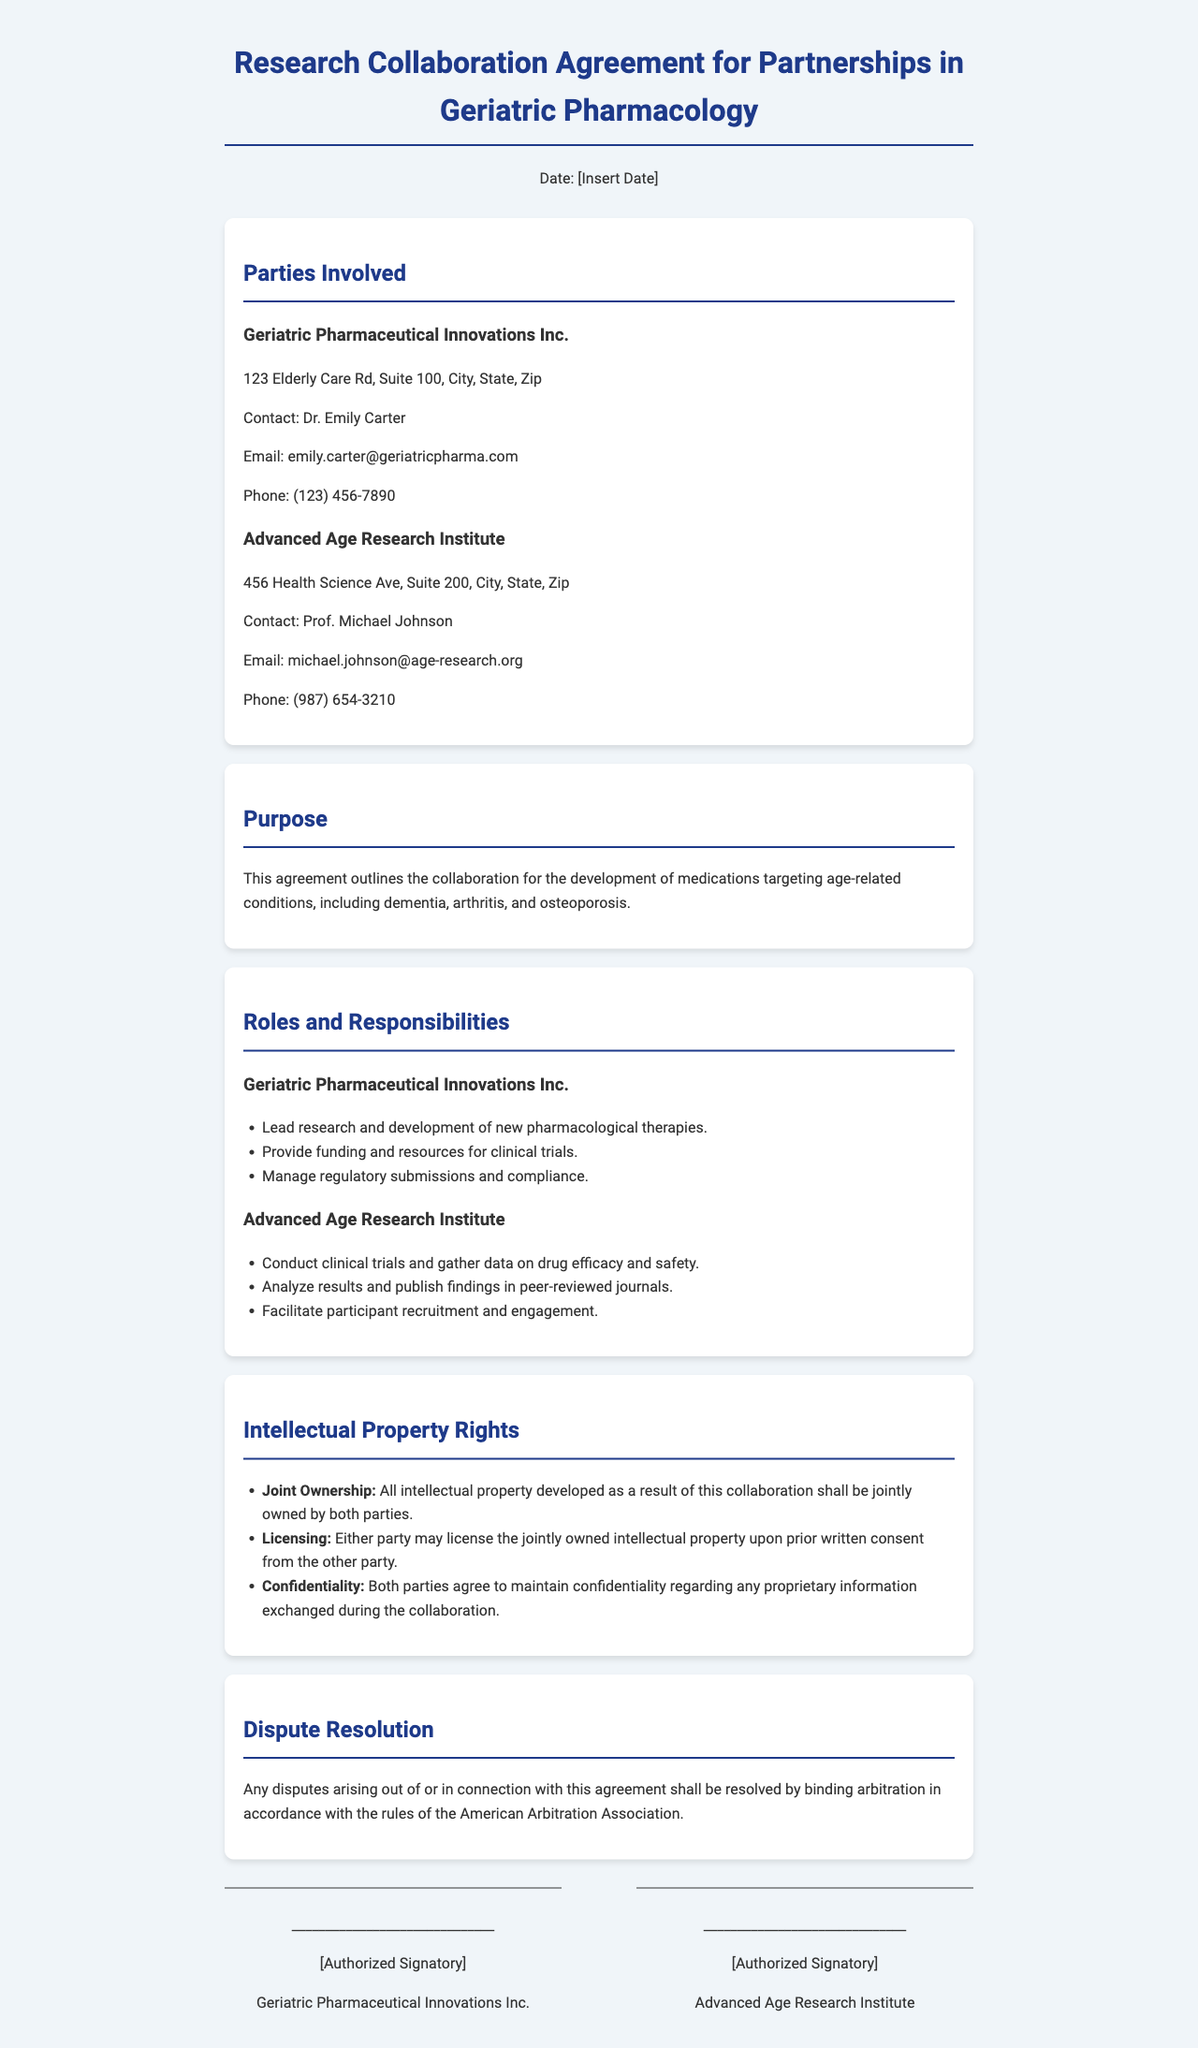what is the name of the first party involved? The first party listed in the document is Geriatric Pharmaceutical Innovations Inc.
Answer: Geriatric Pharmaceutical Innovations Inc who is the contact person for Advanced Age Research Institute? The document states that the contact person for Advanced Age Research Institute is Prof. Michael Johnson.
Answer: Prof. Michael Johnson what is the primary purpose of this agreement? The document outlines the collaboration for the development of medications targeting age-related conditions.
Answer: Development of medications for age-related conditions how many responsibilities does Geriatric Pharmaceutical Innovations Inc. have listed? The responsibilities of Geriatric Pharmaceutical Innovations Inc. are listed as three items in the document.
Answer: Three who conducts clinical trials according to the agreement? The agreement specifies that Advanced Age Research Institute is responsible for conducting clinical trials.
Answer: Advanced Age Research Institute what rights are attributed to the ownership of intellectual property? The document indicates that all intellectual property developed is jointly owned by both parties.
Answer: Joint Ownership how will disputes be resolved as per the document? The document states that disputes shall be resolved by binding arbitration in accordance with specific rules.
Answer: Binding arbitration what must be obtained before licensing the joint intellectual property? According to the document, prior written consent from the other party must be obtained.
Answer: Prior written consent who signs the agreement on behalf of Geriatric Pharmaceutical Innovations Inc.? The document provides a space for an authorized signatory from Geriatric Pharmaceutical Innovations Inc. to sign.
Answer: Authorized Signatory 